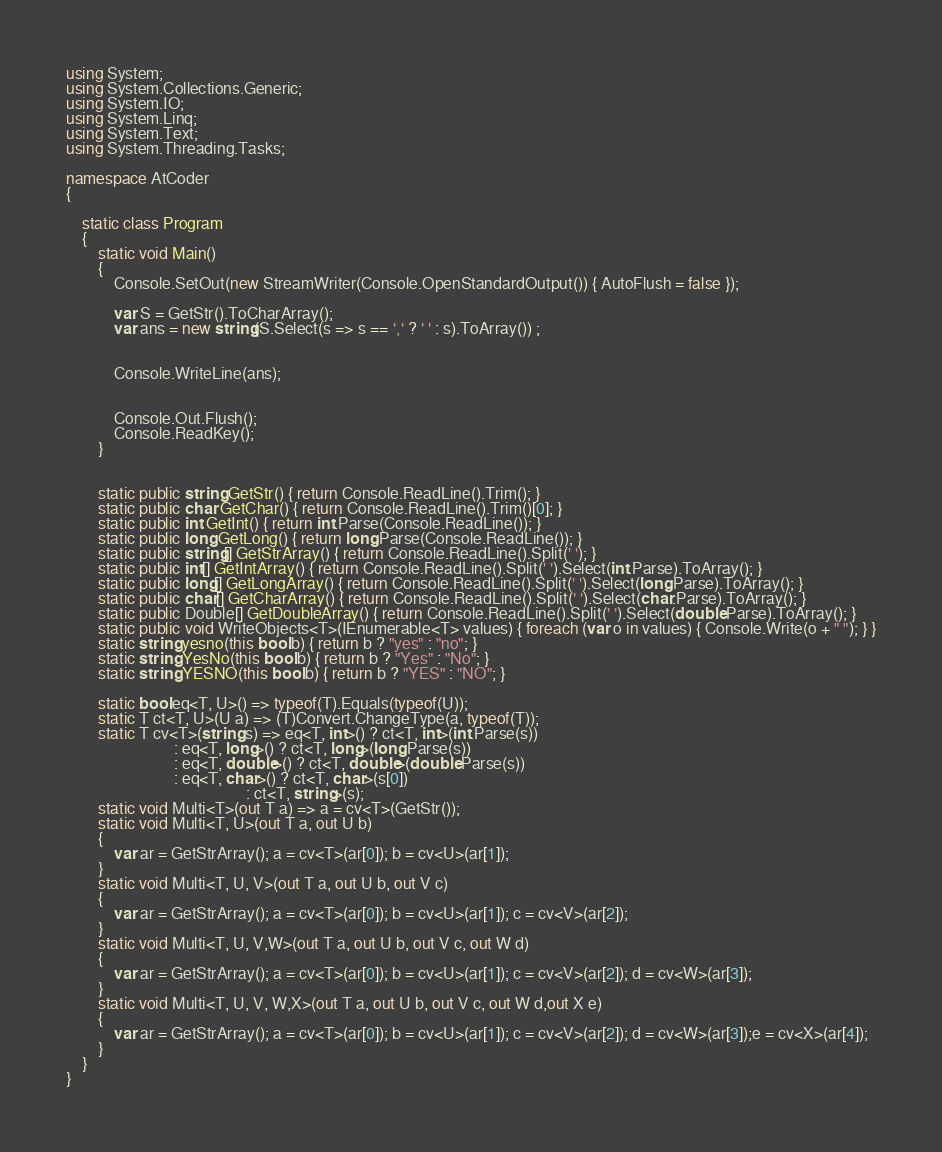<code> <loc_0><loc_0><loc_500><loc_500><_C#_>using System;
using System.Collections.Generic;
using System.IO;
using System.Linq;
using System.Text;
using System.Threading.Tasks;

namespace AtCoder
{

    static class Program
    {
        static void Main()
        {
            Console.SetOut(new StreamWriter(Console.OpenStandardOutput()) { AutoFlush = false });

            var S = GetStr().ToCharArray();
            var ans = new string(S.Select(s => s == ',' ? ' ' : s).ToArray()) ;


            Console.WriteLine(ans);


            Console.Out.Flush();
            Console.ReadKey();
        }


        static public string GetStr() { return Console.ReadLine().Trim(); }
        static public char GetChar() { return Console.ReadLine().Trim()[0]; }
        static public int GetInt() { return int.Parse(Console.ReadLine()); }
        static public long GetLong() { return long.Parse(Console.ReadLine()); }
        static public string[] GetStrArray() { return Console.ReadLine().Split(' '); }
        static public int[] GetIntArray() { return Console.ReadLine().Split(' ').Select(int.Parse).ToArray(); }
        static public long[] GetLongArray() { return Console.ReadLine().Split(' ').Select(long.Parse).ToArray(); }
        static public char[] GetCharArray() { return Console.ReadLine().Split(' ').Select(char.Parse).ToArray(); }
        static public Double[] GetDoubleArray() { return Console.ReadLine().Split(' ').Select(double.Parse).ToArray(); }
        static public void WriteObjects<T>(IEnumerable<T> values) { foreach (var o in values) { Console.Write(o + " "); } }
        static string yesno(this bool b) { return b ? "yes" : "no"; }
        static string YesNo(this bool b) { return b ? "Yes" : "No"; }
        static string YESNO(this bool b) { return b ? "YES" : "NO"; }

        static bool eq<T, U>() => typeof(T).Equals(typeof(U));
        static T ct<T, U>(U a) => (T)Convert.ChangeType(a, typeof(T));
        static T cv<T>(string s) => eq<T, int>() ? ct<T, int>(int.Parse(s))
                           : eq<T, long>() ? ct<T, long>(long.Parse(s))
                           : eq<T, double>() ? ct<T, double>(double.Parse(s))
                           : eq<T, char>() ? ct<T, char>(s[0])
                                             : ct<T, string>(s);
        static void Multi<T>(out T a) => a = cv<T>(GetStr());
        static void Multi<T, U>(out T a, out U b)
        {
            var ar = GetStrArray(); a = cv<T>(ar[0]); b = cv<U>(ar[1]);
        }
        static void Multi<T, U, V>(out T a, out U b, out V c)
        {
            var ar = GetStrArray(); a = cv<T>(ar[0]); b = cv<U>(ar[1]); c = cv<V>(ar[2]);
        }
        static void Multi<T, U, V,W>(out T a, out U b, out V c, out W d)
        {
            var ar = GetStrArray(); a = cv<T>(ar[0]); b = cv<U>(ar[1]); c = cv<V>(ar[2]); d = cv<W>(ar[3]);
        }
        static void Multi<T, U, V, W,X>(out T a, out U b, out V c, out W d,out X e)
        {
            var ar = GetStrArray(); a = cv<T>(ar[0]); b = cv<U>(ar[1]); c = cv<V>(ar[2]); d = cv<W>(ar[3]);e = cv<X>(ar[4]);
        }
    }
}</code> 